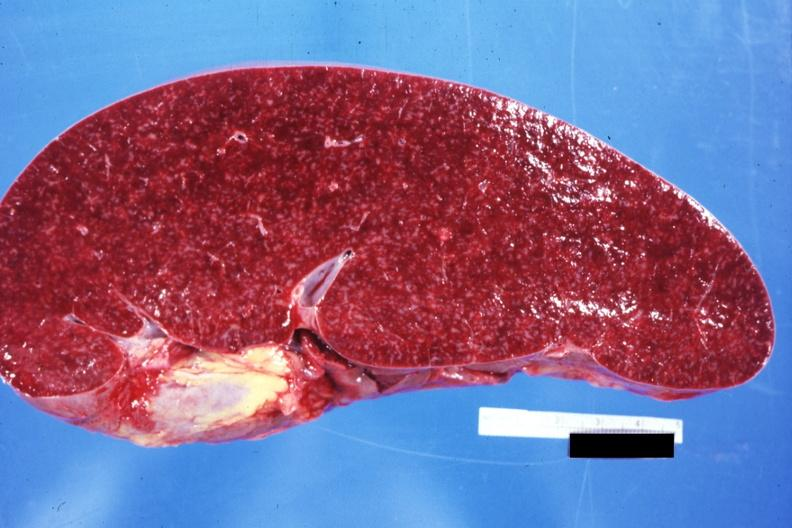how does cut surface prominent lymph follicles size appear see other sides this case?
Answer the question using a single word or phrase. Normal 